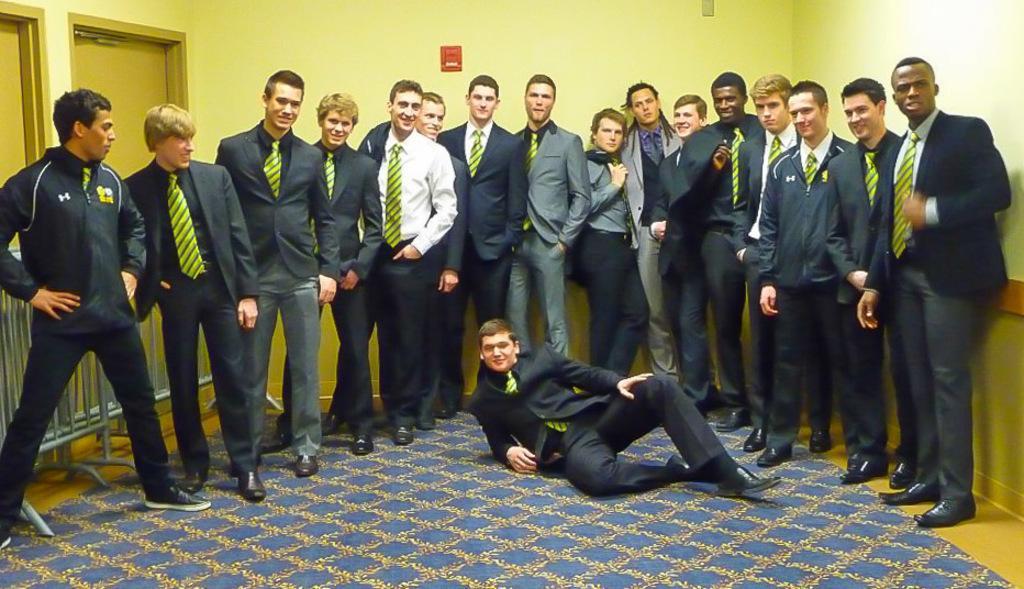Could you give a brief overview of what you see in this image? Here we can see people. These people wore suits. Floor with carpet. Background there is a wall. Here we can see fence and doors. 